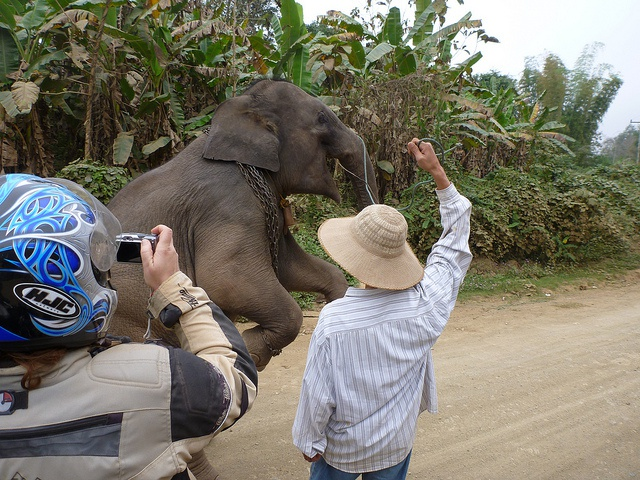Describe the objects in this image and their specific colors. I can see people in darkgreen, darkgray, black, and gray tones, elephant in darkgreen, gray, and black tones, and people in darkgreen, darkgray, lavender, and gray tones in this image. 